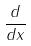Convert formula to latex. <formula><loc_0><loc_0><loc_500><loc_500>\frac { d } { d x }</formula> 